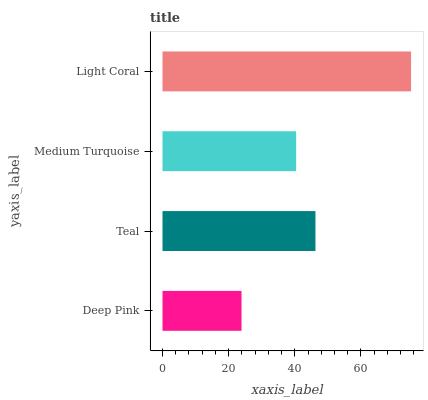Is Deep Pink the minimum?
Answer yes or no. Yes. Is Light Coral the maximum?
Answer yes or no. Yes. Is Teal the minimum?
Answer yes or no. No. Is Teal the maximum?
Answer yes or no. No. Is Teal greater than Deep Pink?
Answer yes or no. Yes. Is Deep Pink less than Teal?
Answer yes or no. Yes. Is Deep Pink greater than Teal?
Answer yes or no. No. Is Teal less than Deep Pink?
Answer yes or no. No. Is Teal the high median?
Answer yes or no. Yes. Is Medium Turquoise the low median?
Answer yes or no. Yes. Is Deep Pink the high median?
Answer yes or no. No. Is Light Coral the low median?
Answer yes or no. No. 